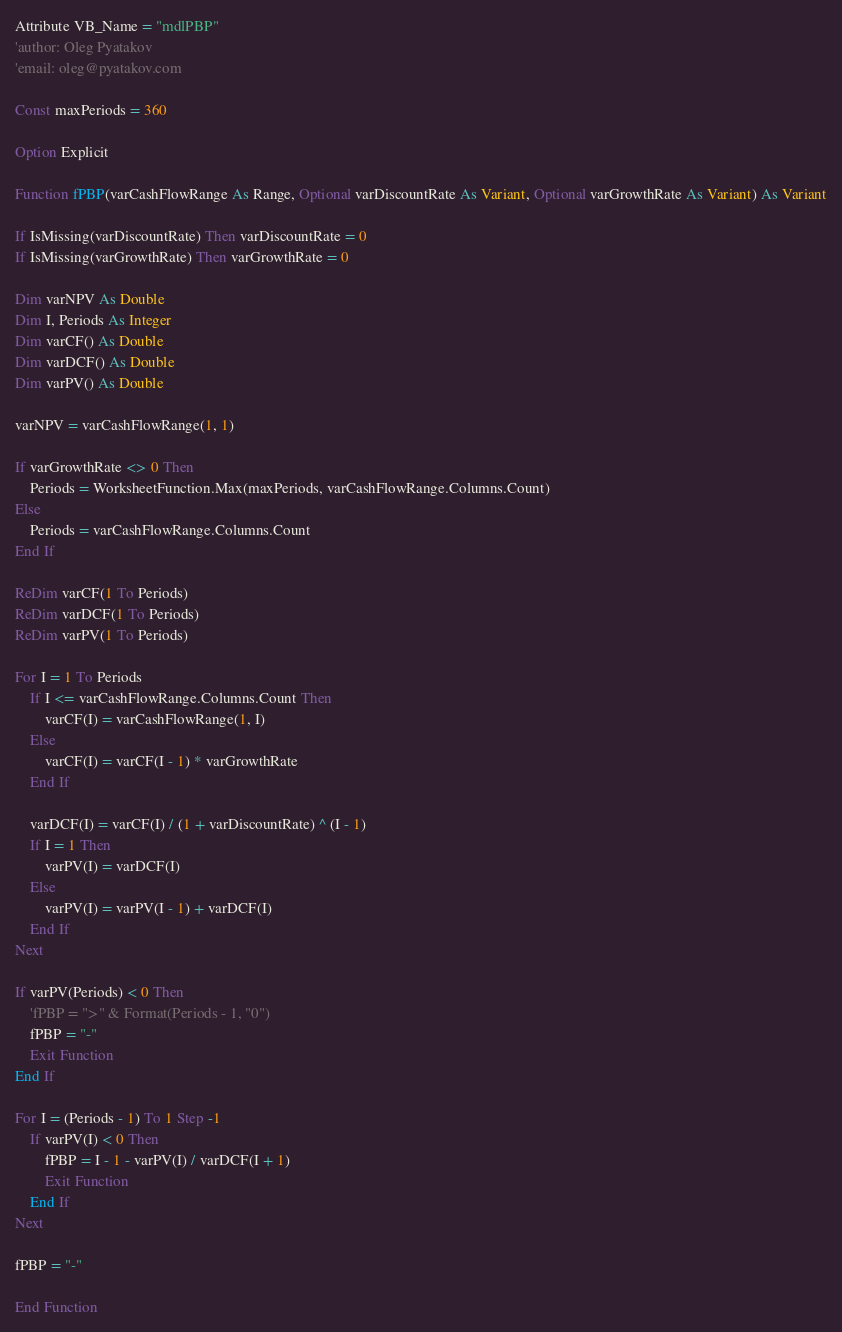<code> <loc_0><loc_0><loc_500><loc_500><_VisualBasic_>Attribute VB_Name = "mdlPBP"
'author: Oleg Pyatakov
'email: oleg@pyatakov.com

Const maxPeriods = 360

Option Explicit

Function fPBP(varCashFlowRange As Range, Optional varDiscountRate As Variant, Optional varGrowthRate As Variant) As Variant

If IsMissing(varDiscountRate) Then varDiscountRate = 0
If IsMissing(varGrowthRate) Then varGrowthRate = 0

Dim varNPV As Double
Dim I, Periods As Integer
Dim varCF() As Double
Dim varDCF() As Double
Dim varPV() As Double

varNPV = varCashFlowRange(1, 1)

If varGrowthRate <> 0 Then
    Periods = WorksheetFunction.Max(maxPeriods, varCashFlowRange.Columns.Count)
Else
    Periods = varCashFlowRange.Columns.Count
End If

ReDim varCF(1 To Periods)
ReDim varDCF(1 To Periods)
ReDim varPV(1 To Periods)

For I = 1 To Periods
    If I <= varCashFlowRange.Columns.Count Then
        varCF(I) = varCashFlowRange(1, I)
    Else
        varCF(I) = varCF(I - 1) * varGrowthRate
    End If
    
    varDCF(I) = varCF(I) / (1 + varDiscountRate) ^ (I - 1)
    If I = 1 Then
        varPV(I) = varDCF(I)
    Else
        varPV(I) = varPV(I - 1) + varDCF(I)
    End If
Next

If varPV(Periods) < 0 Then
    'fPBP = ">" & Format(Periods - 1, "0")
    fPBP = "-"
    Exit Function
End If

For I = (Periods - 1) To 1 Step -1
    If varPV(I) < 0 Then
        fPBP = I - 1 - varPV(I) / varDCF(I + 1)
        Exit Function
    End If
Next

fPBP = "-"

End Function
</code> 